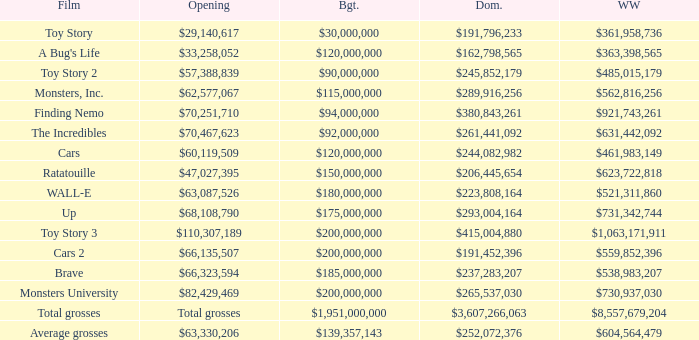WHAT IS THE OPENING WITH A WORLDWIDE NUMBER OF $559,852,396? $66,135,507. 